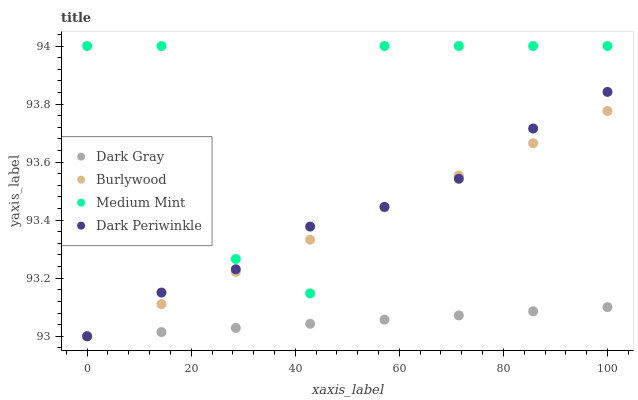Does Dark Gray have the minimum area under the curve?
Answer yes or no. Yes. Does Medium Mint have the maximum area under the curve?
Answer yes or no. Yes. Does Burlywood have the minimum area under the curve?
Answer yes or no. No. Does Burlywood have the maximum area under the curve?
Answer yes or no. No. Is Burlywood the smoothest?
Answer yes or no. Yes. Is Medium Mint the roughest?
Answer yes or no. Yes. Is Dark Periwinkle the smoothest?
Answer yes or no. No. Is Dark Periwinkle the roughest?
Answer yes or no. No. Does Dark Gray have the lowest value?
Answer yes or no. Yes. Does Medium Mint have the lowest value?
Answer yes or no. No. Does Medium Mint have the highest value?
Answer yes or no. Yes. Does Burlywood have the highest value?
Answer yes or no. No. Is Dark Gray less than Medium Mint?
Answer yes or no. Yes. Is Medium Mint greater than Dark Gray?
Answer yes or no. Yes. Does Dark Periwinkle intersect Medium Mint?
Answer yes or no. Yes. Is Dark Periwinkle less than Medium Mint?
Answer yes or no. No. Is Dark Periwinkle greater than Medium Mint?
Answer yes or no. No. Does Dark Gray intersect Medium Mint?
Answer yes or no. No. 